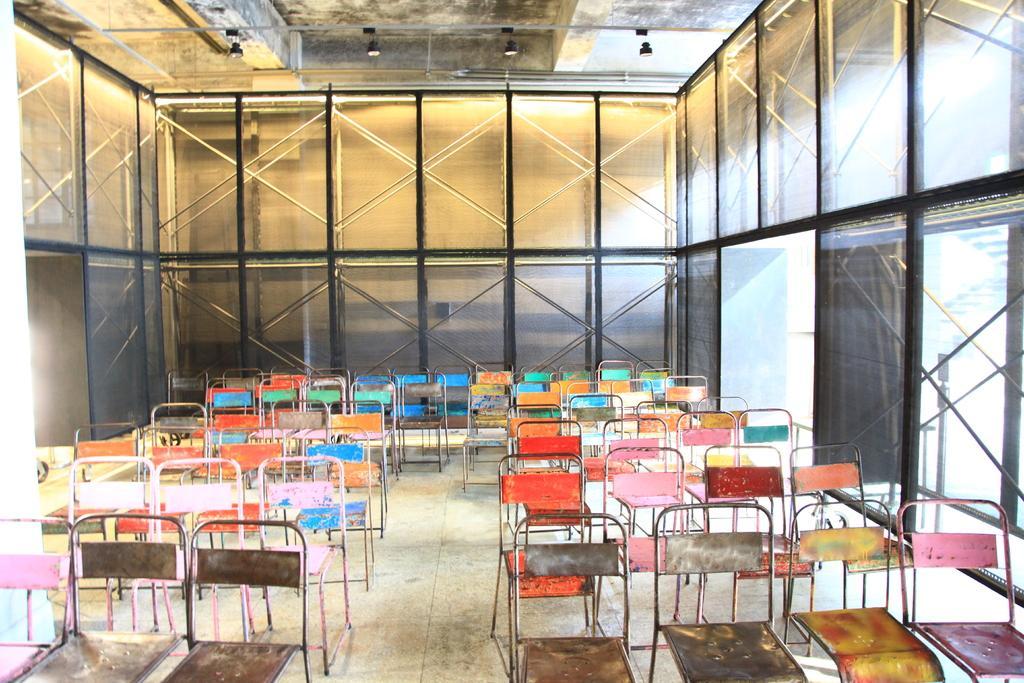Describe this image in one or two sentences. In this image at the bottom there are a group of chairs, and in the background there is a wall and some poles and lights. 